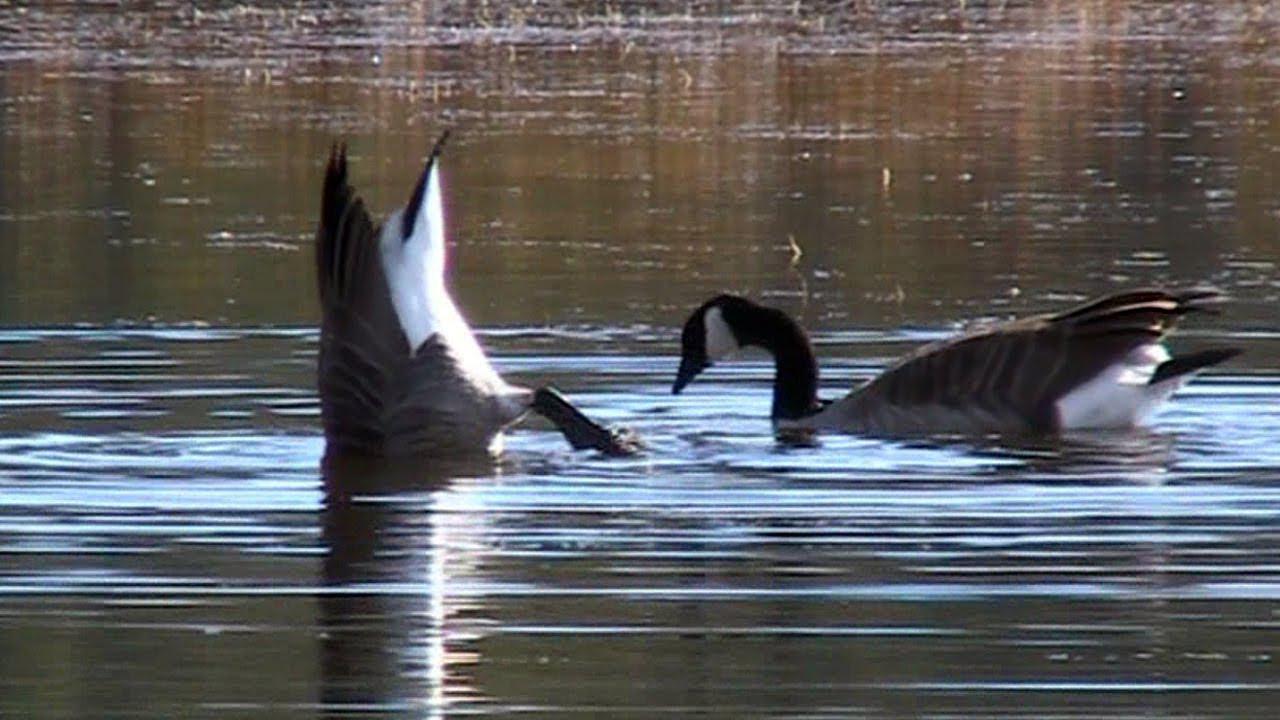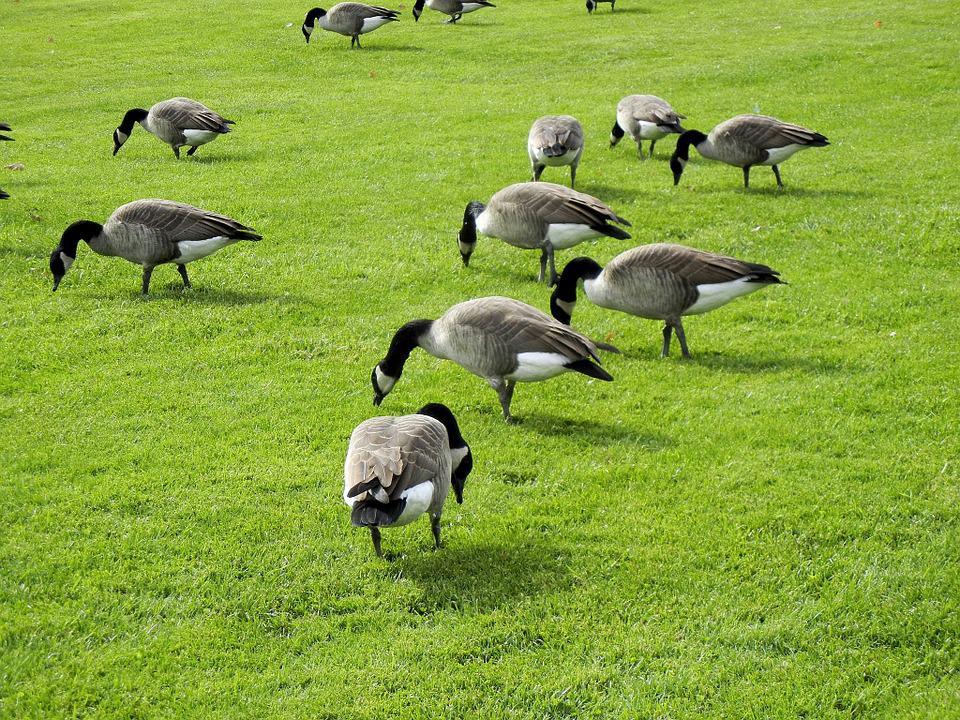The first image is the image on the left, the second image is the image on the right. Given the left and right images, does the statement "There is a single black and gray goose grazing in the grass." hold true? Answer yes or no. No. The first image is the image on the left, the second image is the image on the right. Given the left and right images, does the statement "In one of the image the geese are in the water." hold true? Answer yes or no. Yes. 